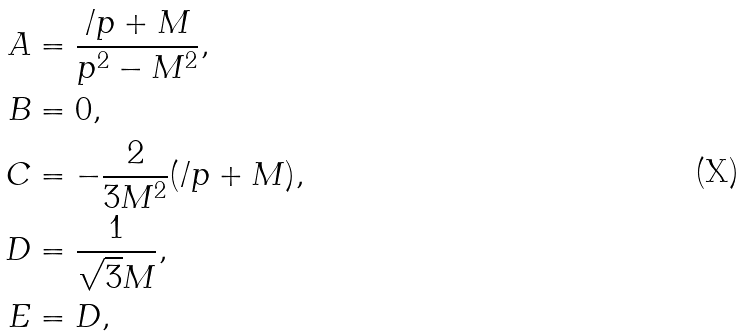<formula> <loc_0><loc_0><loc_500><loc_500>A & = \frac { \slash p + M } { p ^ { 2 } - M ^ { 2 } } , \\ B & = 0 , \\ C & = - \frac { 2 } { 3 M ^ { 2 } } ( \slash p + M ) , \\ D & = \frac { 1 } { \sqrt { 3 } M } , \\ E & = D , \\</formula> 